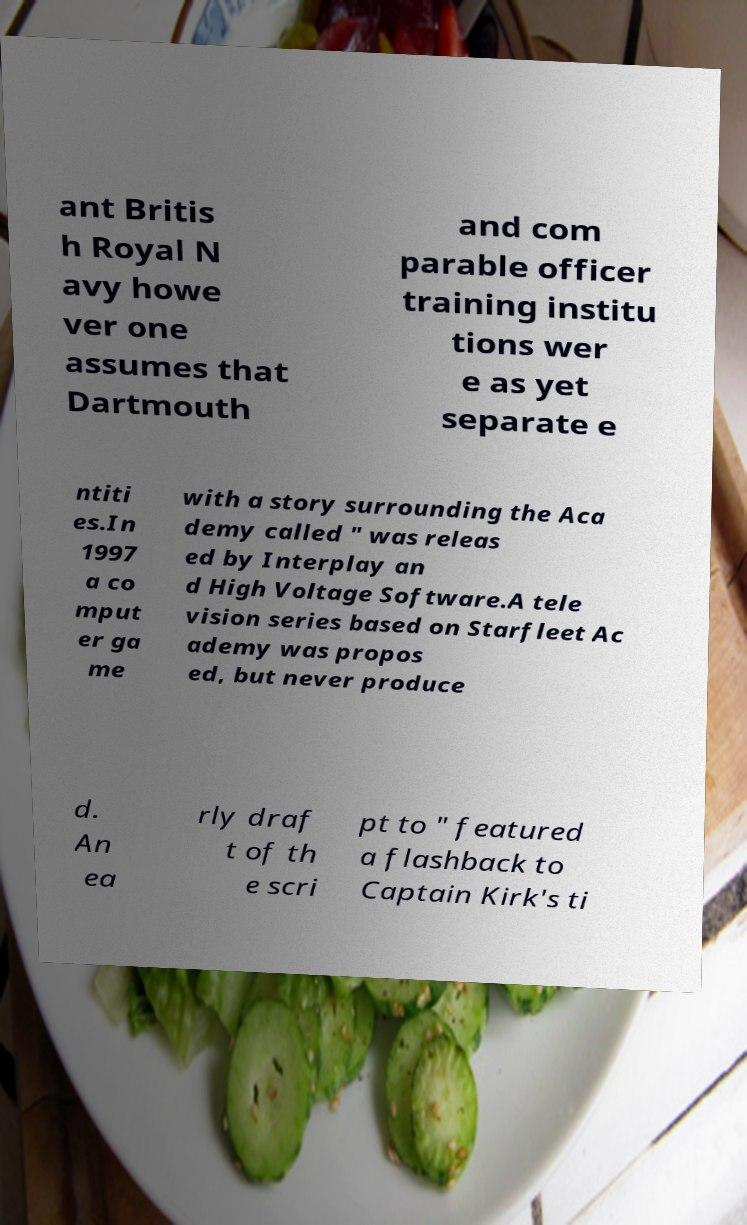Could you assist in decoding the text presented in this image and type it out clearly? ant Britis h Royal N avy howe ver one assumes that Dartmouth and com parable officer training institu tions wer e as yet separate e ntiti es.In 1997 a co mput er ga me with a story surrounding the Aca demy called " was releas ed by Interplay an d High Voltage Software.A tele vision series based on Starfleet Ac ademy was propos ed, but never produce d. An ea rly draf t of th e scri pt to " featured a flashback to Captain Kirk's ti 